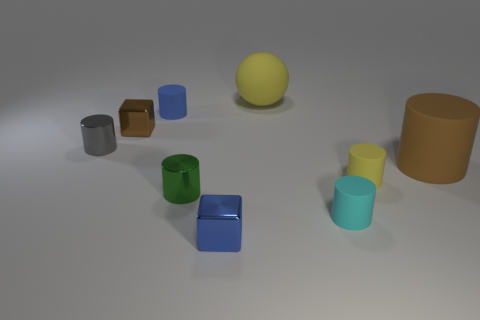What is the color of the cylinder that is the same material as the tiny gray thing?
Make the answer very short. Green. There is a large matte thing right of the small yellow rubber cylinder; is there a block that is in front of it?
Provide a succinct answer. Yes. There is a rubber thing that is the same size as the ball; what color is it?
Provide a short and direct response. Brown. What number of objects are either tiny gray cylinders or brown things?
Your response must be concise. 3. What is the size of the yellow thing to the right of the matte thing that is in front of the small green metal cylinder that is to the left of the large matte cylinder?
Provide a short and direct response. Small. How many shiny cylinders are the same color as the big sphere?
Provide a succinct answer. 0. What number of tiny brown blocks are the same material as the tiny gray object?
Offer a very short reply. 1. How many objects are either blocks or objects in front of the tiny green cylinder?
Your answer should be compact. 3. What color is the rubber cylinder on the left side of the small metal cube right of the brown thing that is left of the tiny blue matte cylinder?
Your response must be concise. Blue. How big is the cube in front of the tiny yellow cylinder?
Your response must be concise. Small. 